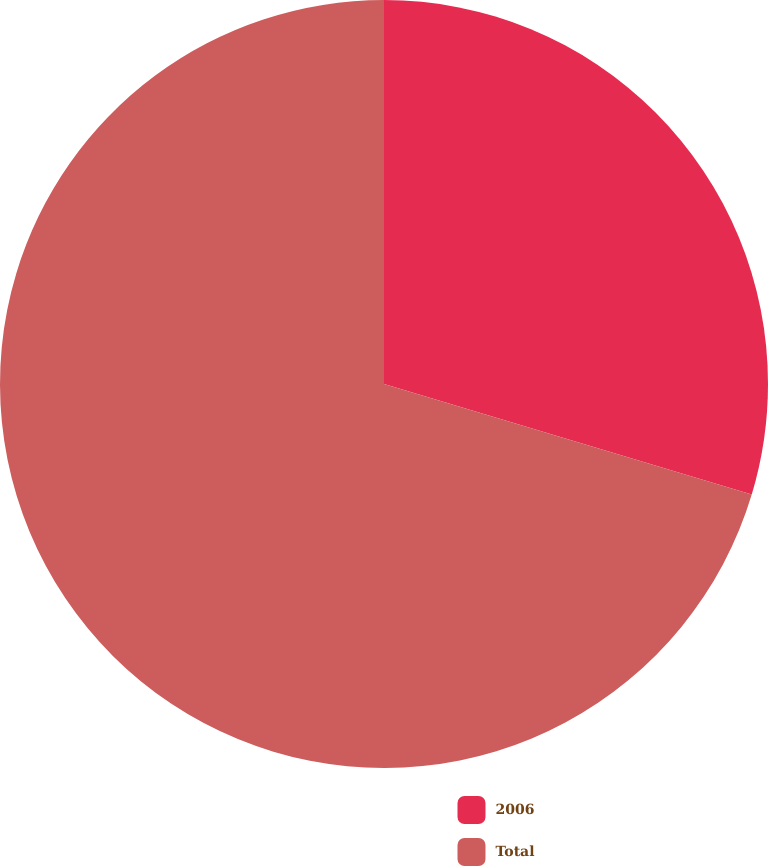<chart> <loc_0><loc_0><loc_500><loc_500><pie_chart><fcel>2006<fcel>Total<nl><fcel>29.65%<fcel>70.35%<nl></chart> 